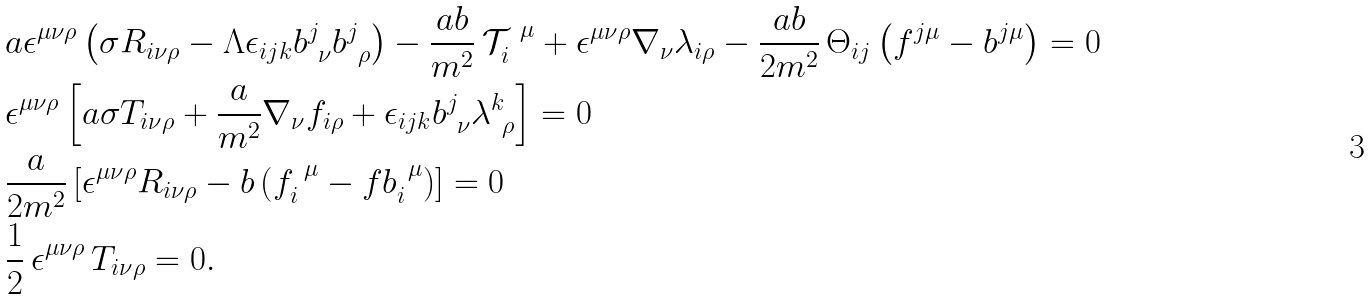Convert formula to latex. <formula><loc_0><loc_0><loc_500><loc_500>& a \epsilon ^ { \mu \nu \rho } \left ( \sigma R _ { i \nu \rho } - \Lambda \epsilon _ { i j k } b ^ { j } _ { \ \nu } b ^ { j } _ { \ \rho } \right ) - \frac { a b } { m ^ { 2 } } \, \mathcal { T } _ { i } ^ { \ \mu } + \epsilon ^ { \mu \nu \rho } \nabla _ { \nu } \lambda _ { i \rho } - \frac { a b } { 2 m ^ { 2 } } \, \Theta _ { i j } \left ( f ^ { j \mu } - b ^ { j \mu } \right ) = 0 \\ & \epsilon ^ { \mu \nu \rho } \left [ a \sigma T _ { i \nu \rho } + \frac { a } { m ^ { 2 } } \nabla _ { \nu } f _ { i \rho } + \epsilon _ { i j k } b ^ { j } _ { \ \nu } \lambda ^ { k } _ { \ \rho } \right ] = 0 \\ & \frac { a } { 2 m ^ { 2 } } \left [ \epsilon ^ { \mu \nu \rho } R _ { i \nu \rho } - b \left ( f _ { i } ^ { \ \mu } - f b _ { i } ^ { \ \mu } \right ) \right ] = 0 \\ & \frac { 1 } { 2 } \, \epsilon ^ { \mu \nu \rho } \, T _ { i \nu \rho } = 0 .</formula> 